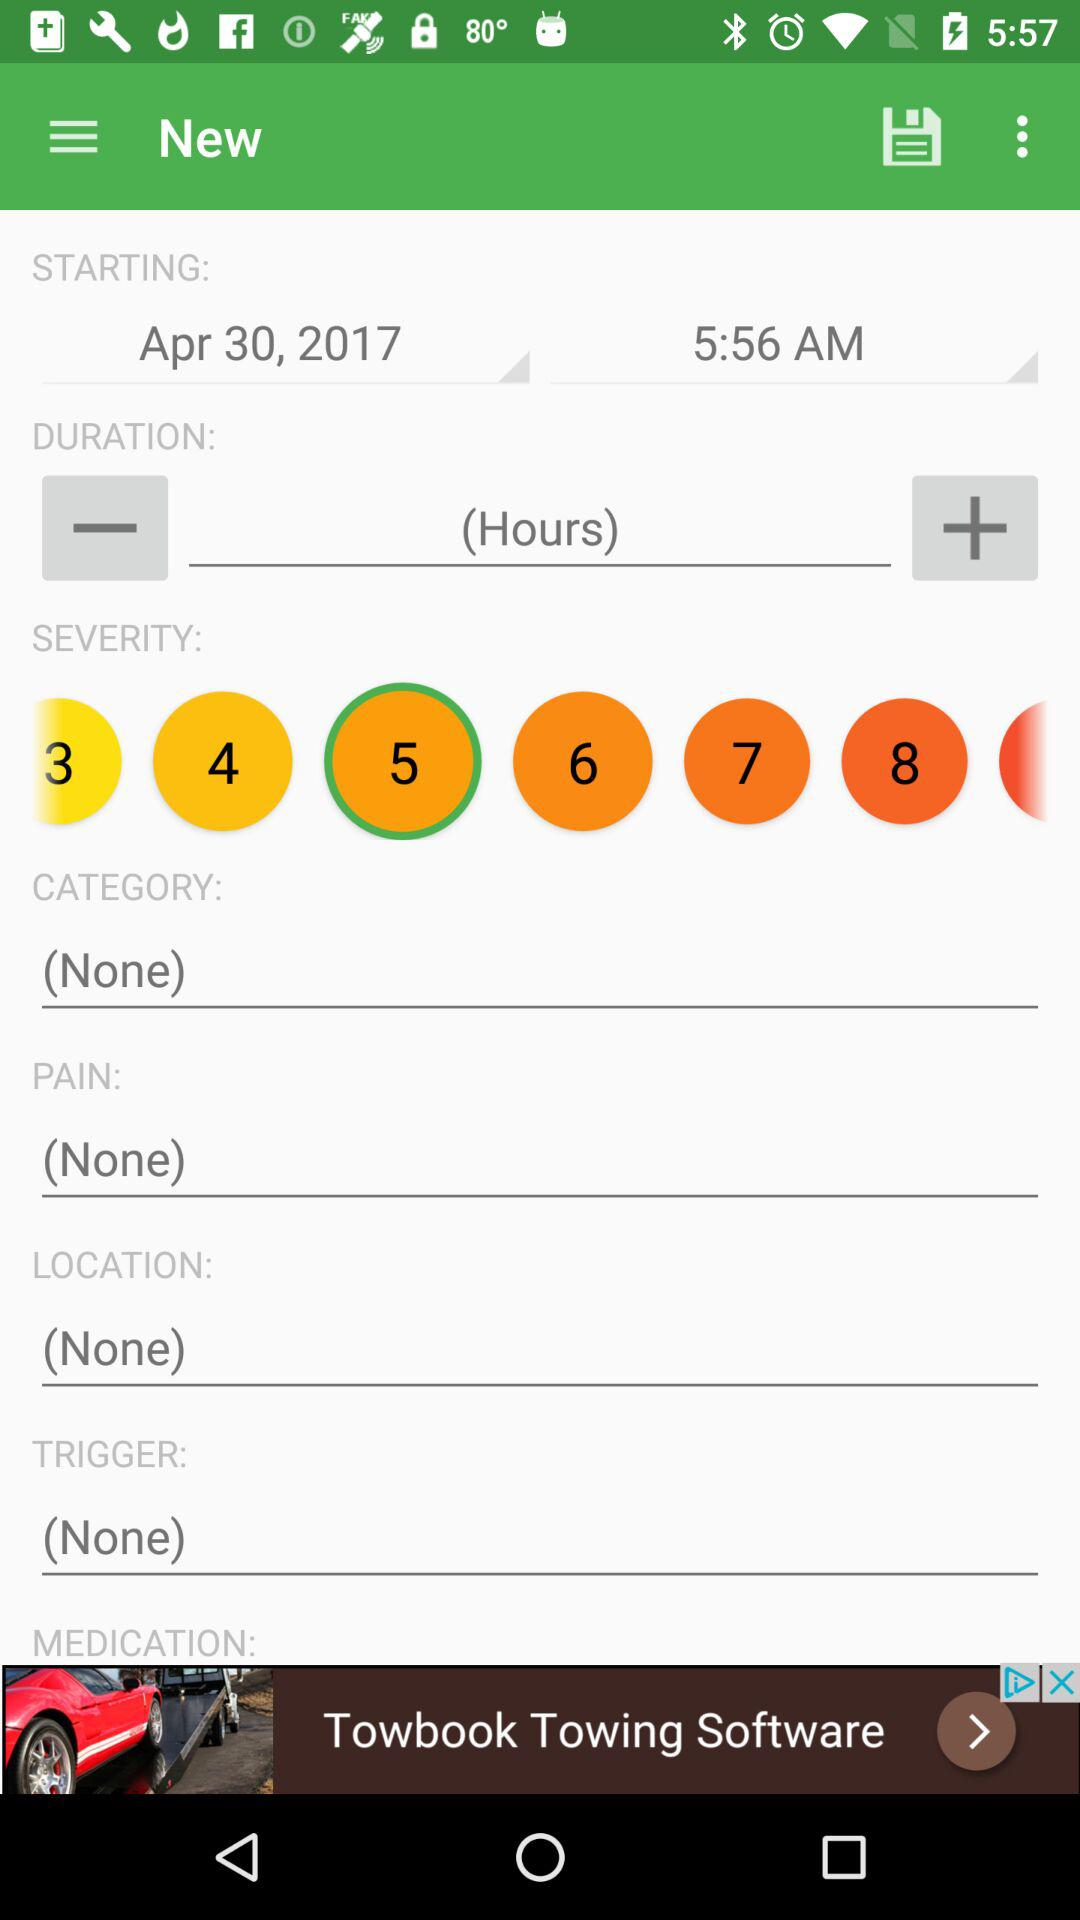What is the selected severity level? The selected severity level is 5. 